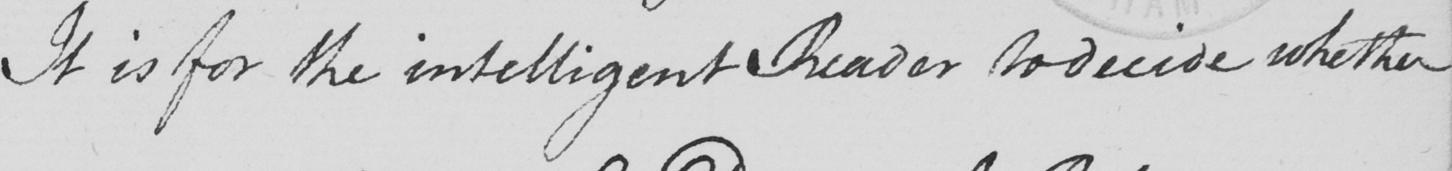What text is written in this handwritten line? It is for the intelligent Reader to decide whether 